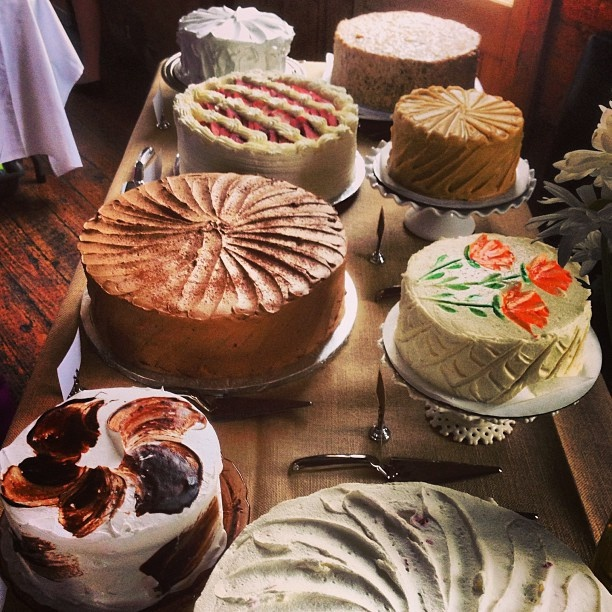Describe the objects in this image and their specific colors. I can see cake in darkgray, maroon, tan, and brown tones, cake in darkgray, black, maroon, lightgray, and brown tones, cake in darkgray, lightgray, gray, and tan tones, dining table in darkgray, black, maroon, and gray tones, and cake in darkgray, olive, and tan tones in this image. 